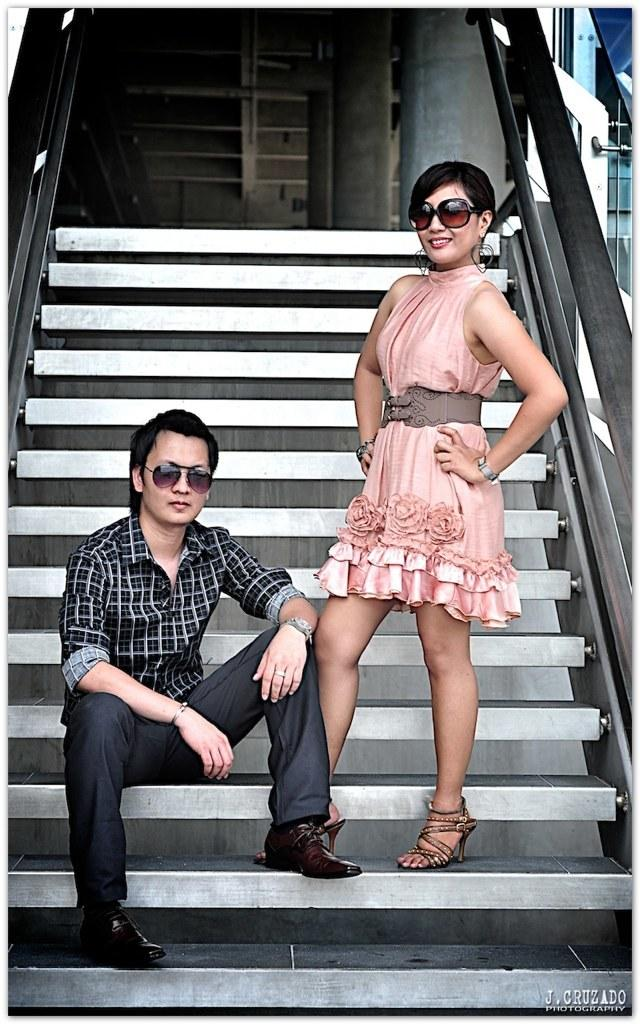What type of structure is present in the image? There are stairs in the image. What feature is present on the stairs for safety? There are railings on the stairs. What is the man in the image doing? A man is sitting on the stairs. Who is with the man on the stairs? A woman is standing beside the man. What type of cherry is the man eating on the stairs? There is no cherry present in the image; the man is not eating anything. What breed of dog is sitting with the woman on the stairs? There are no dogs present in the image; only the man and woman are visible. 